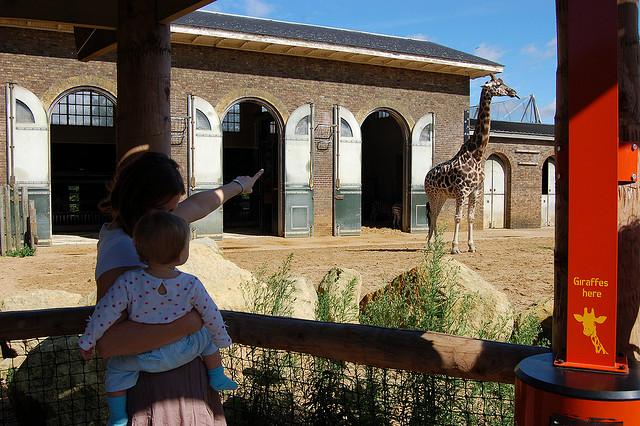Is the woman wearing a backpack?
Write a very short answer. No. Is that a mother pointing?
Give a very brief answer. Yes. How many animals can be seen?
Concise answer only. 1. What animal is painted on the red post?
Give a very brief answer. Giraffe. 